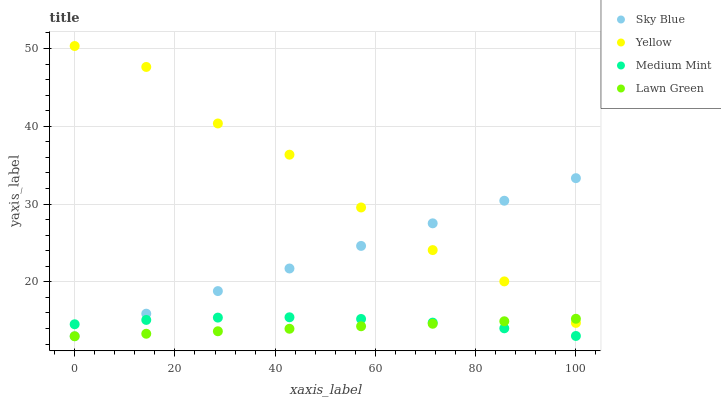Does Lawn Green have the minimum area under the curve?
Answer yes or no. Yes. Does Yellow have the maximum area under the curve?
Answer yes or no. Yes. Does Sky Blue have the minimum area under the curve?
Answer yes or no. No. Does Sky Blue have the maximum area under the curve?
Answer yes or no. No. Is Lawn Green the smoothest?
Answer yes or no. Yes. Is Yellow the roughest?
Answer yes or no. Yes. Is Sky Blue the smoothest?
Answer yes or no. No. Is Sky Blue the roughest?
Answer yes or no. No. Does Sky Blue have the lowest value?
Answer yes or no. Yes. Does Yellow have the lowest value?
Answer yes or no. No. Does Yellow have the highest value?
Answer yes or no. Yes. Does Sky Blue have the highest value?
Answer yes or no. No. Is Medium Mint less than Yellow?
Answer yes or no. Yes. Is Yellow greater than Medium Mint?
Answer yes or no. Yes. Does Lawn Green intersect Medium Mint?
Answer yes or no. Yes. Is Lawn Green less than Medium Mint?
Answer yes or no. No. Is Lawn Green greater than Medium Mint?
Answer yes or no. No. Does Medium Mint intersect Yellow?
Answer yes or no. No. 